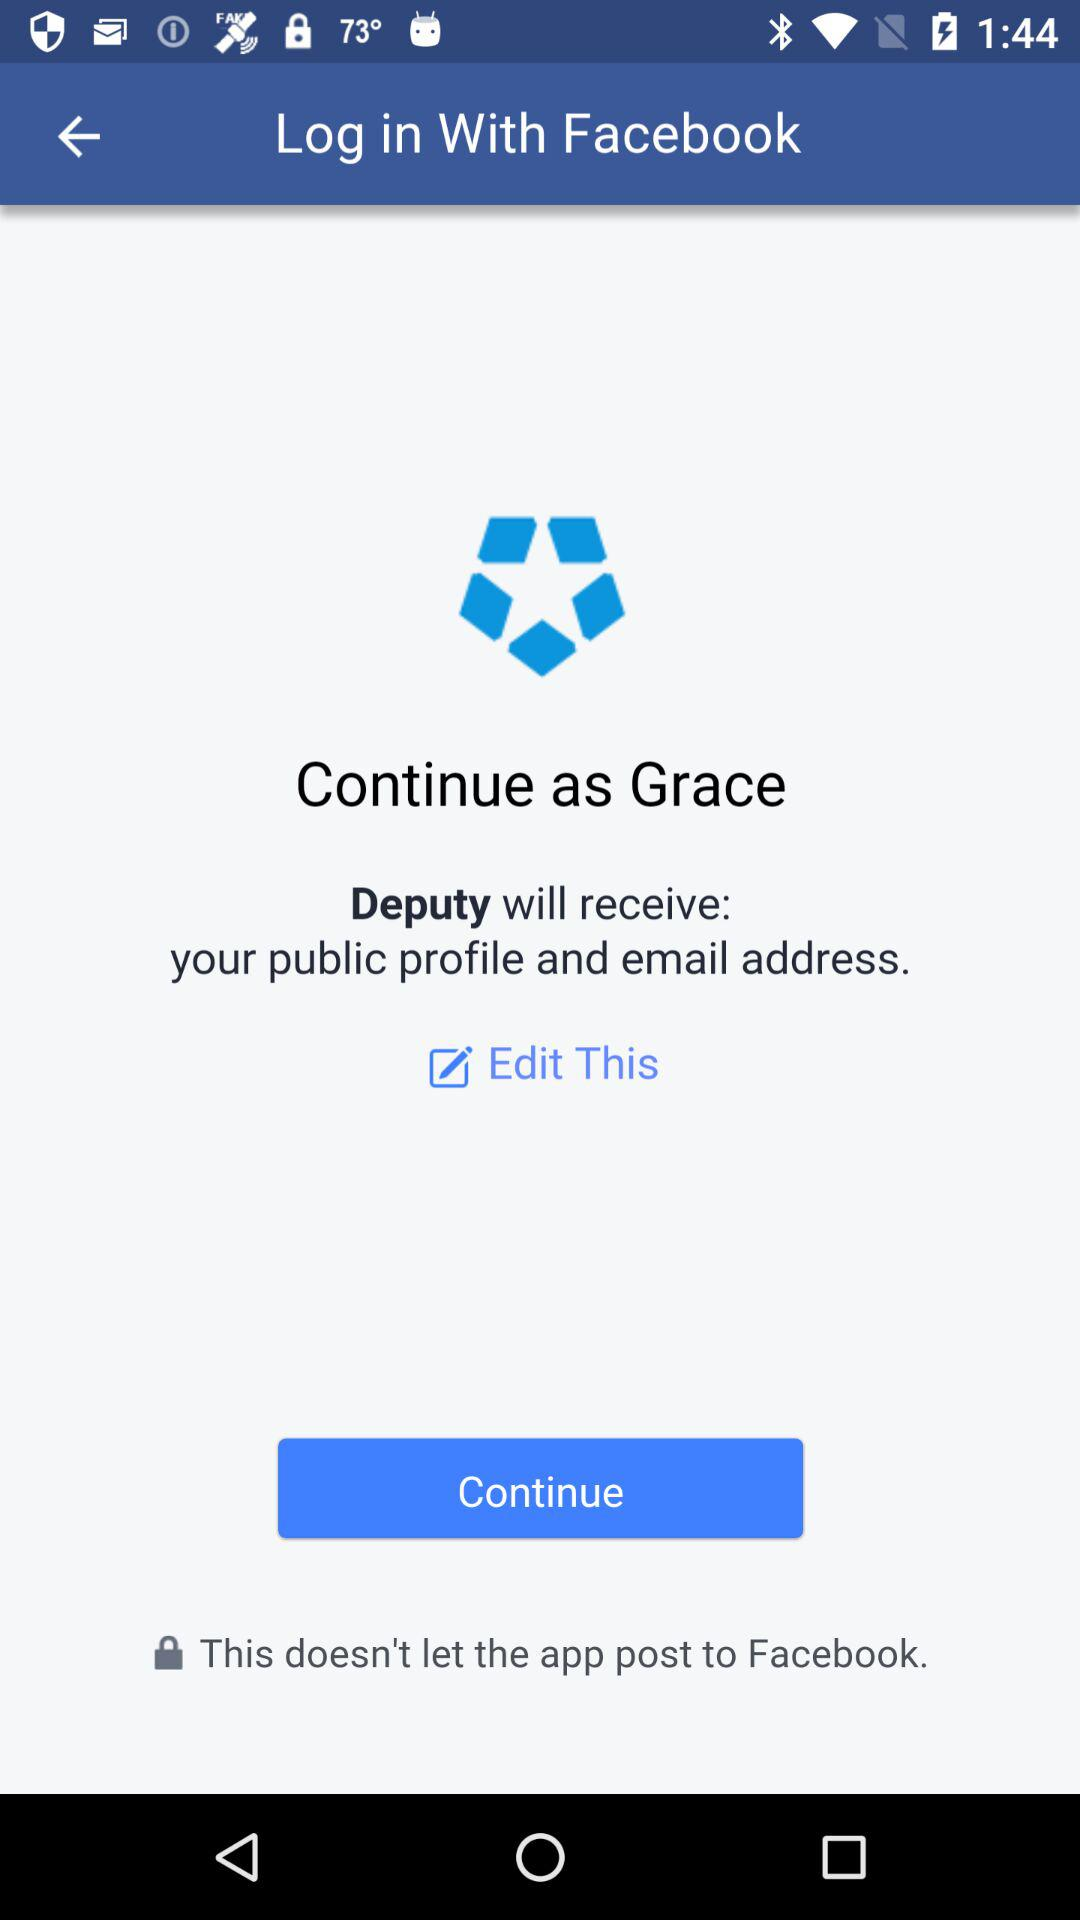What will be received by "Deputy"? The "Deputy" will receive your public profile and email address. 